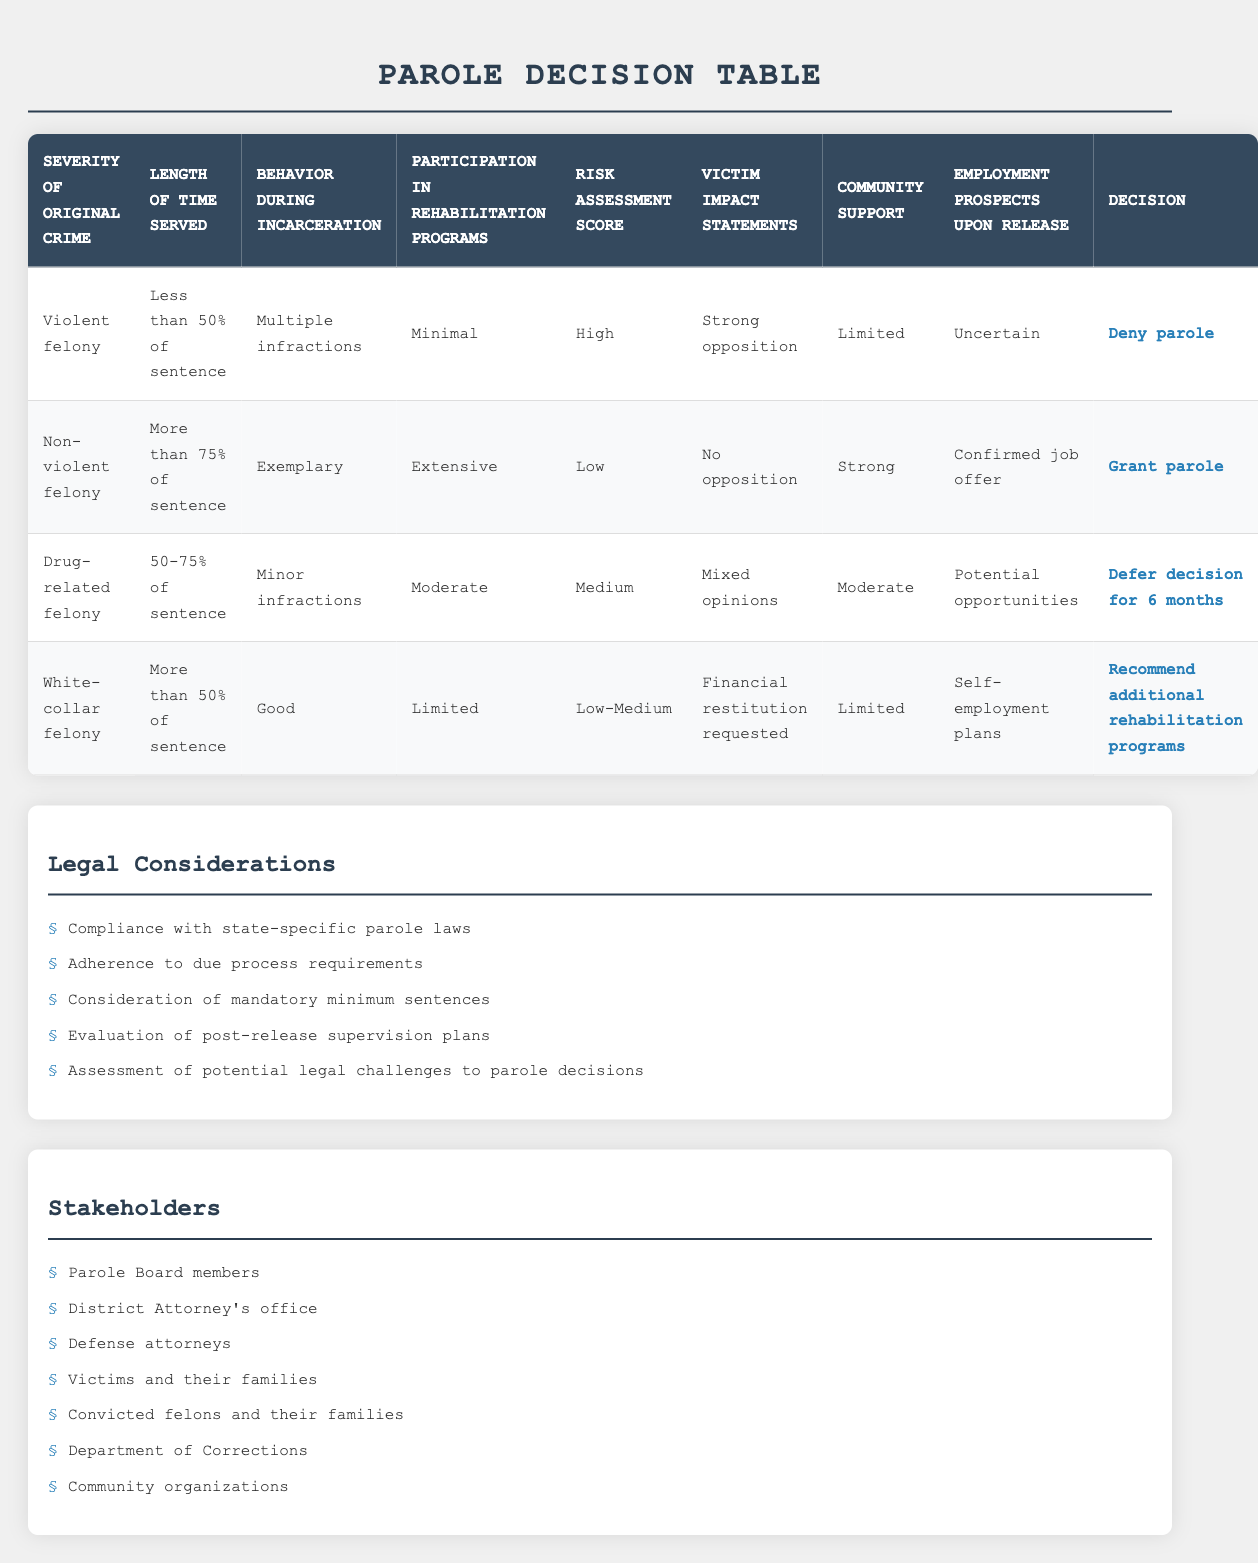What are the conditions for granting parole to a convicted felon who has served more than 75% of their sentence for a non-violent felony? The conditions include: "Severity of original crime" is a "Non-violent felony," "Length of time served" is "More than 75% of sentence," "Behavior during incarceration" is "Exemplary," "Participation in rehabilitation programs" is "Extensive," "Risk assessment score" is "Low," "Victim impact statements" show "No opposition," "Community support" is "Strong," and "Employment prospects upon release" have a "Confirmed job offer."
Answer: The conditions include a non-violent felony, more than 75% of the sentence served, exemplary behavior, extensive rehabilitation participation, a low risk assessment score, no victim opposition, strong community support, and a confirmed job offer Is the recommendation for additional rehabilitation programs given for white-collar felonies? Yes, the action for white-collar felonies with specific conditions, such as serving more than 50% of their sentence and showing limited rehabilitation participation, is to recommend additional rehabilitation programs.
Answer: Yes Which severity of crime leads to denying parole? The severity of crime that leads to denying parole is a "Violent felony" with conditions such as serving less than 50% of the sentence, multiple infractions during incarceration, minimal participation in rehabilitation programs, a high risk assessment score, strong opposition from victims, limited community support, and uncertain employment prospects.
Answer: Violent felony How many total conditions are considered for granting parole? There are 8 conditions listed for consideration in the table: severity of the original crime, length of time served, behavior during incarceration, participation in rehabilitation programs, risk assessment score, victim impact statements, community support, and employment prospects upon release.
Answer: 8 What percentage of cases lead to a deferral decision for drug-related felonies? Based on the rules, only one case, which is for drug-related felonies with specific conditions, leads to deferring the decision for 6 months. Since there are a total of 4 rules, this is 25% (1 out of 4).
Answer: 25% Are there any rules that grant parole with limited community support? No, all rules granting parole require strong community support as a condition. The scenarios granting parole show strong community backing, while cases with limited support lead to other actions.
Answer: No What is the relationship between behavior during incarceration and the decision to grant or deny parole in this table? The behavior during incarceration significantly affects the decision. For instance, exemplary behavior is required for granting parole (for non-violent felonies), while multiple infractions lead to denial (for violent felonies). Thus, good behavior increases the likelihood of parole.
Answer: Good behavior increases likelihood of parole What action is taken when the risk assessment score is high? When the risk assessment score is high, the action taken is to deny parole, specifically in the case of a violent felony where all other unfavorable conditions are also met.
Answer: Deny parole 